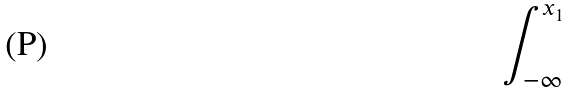Convert formula to latex. <formula><loc_0><loc_0><loc_500><loc_500>\int _ { - \infty } ^ { x _ { 1 } }</formula> 